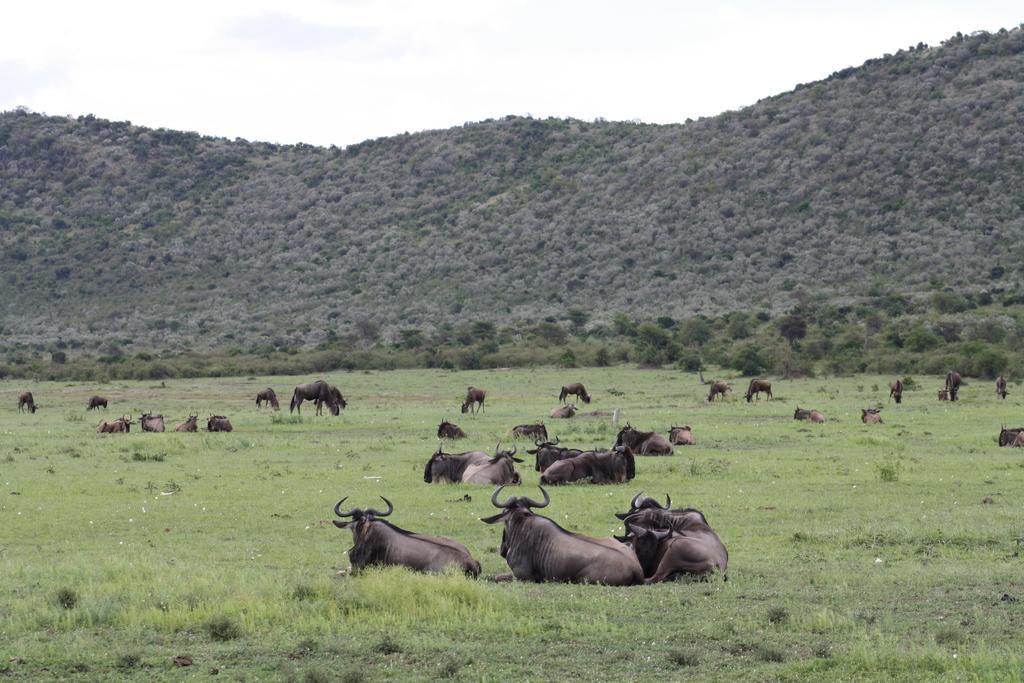Describe this image in one or two sentences. In this image I can see many animals, they are in brown and black color some are sitting and some are standing. Background I can see trees in green color and sky in white color. 